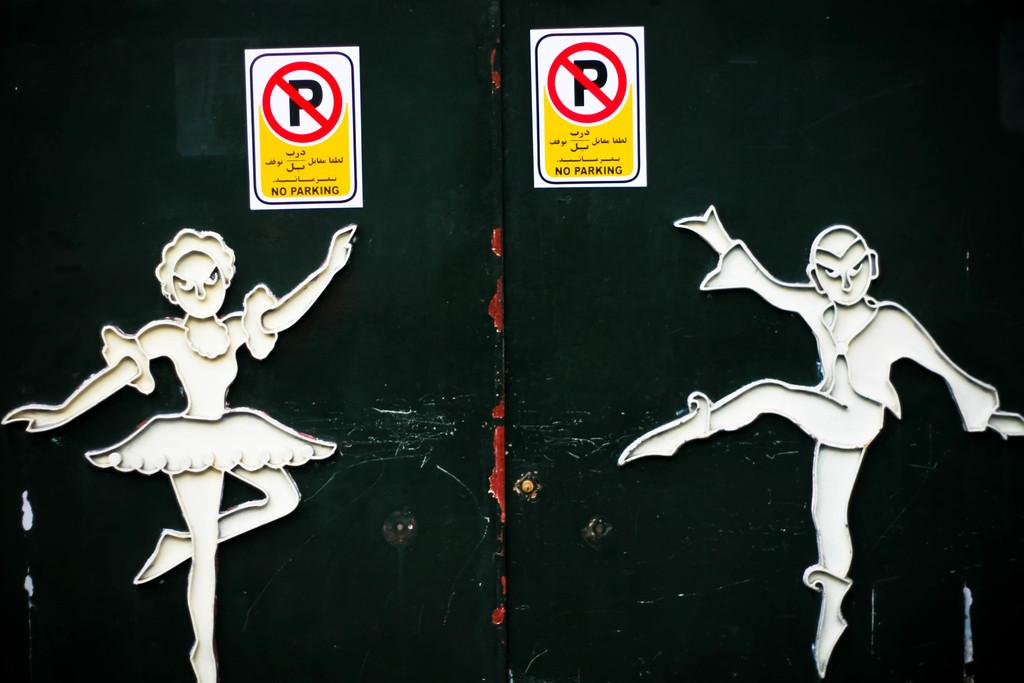How many boards can be seen in the image? There are two boards in the image. What is depicted on the boards? The boards have images on them. Are there any other boards visible in the image? Yes, there are additional boards in the image. How many houses can be seen on the boards in the image? There are no houses depicted on the boards in the image; the boards have images, but they do not include houses. 